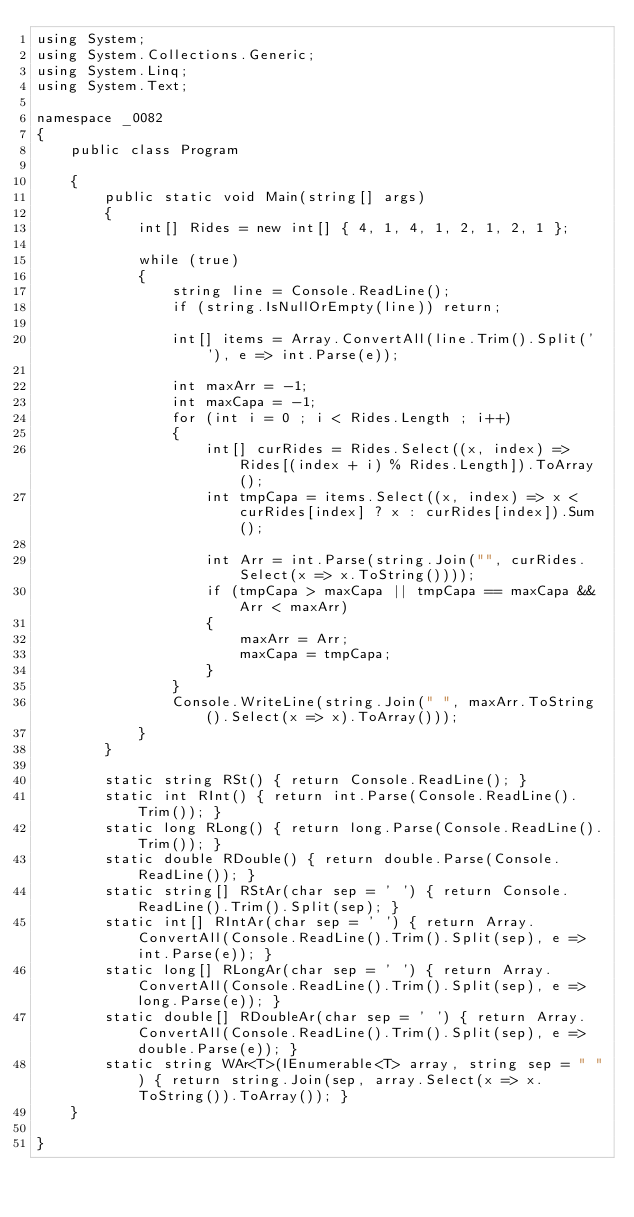<code> <loc_0><loc_0><loc_500><loc_500><_C#_>using System;
using System.Collections.Generic;
using System.Linq;
using System.Text;

namespace _0082
{
    public class Program

    {
        public static void Main(string[] args)
        {
            int[] Rides = new int[] { 4, 1, 4, 1, 2, 1, 2, 1 };

            while (true)
            {
                string line = Console.ReadLine();
                if (string.IsNullOrEmpty(line)) return;

                int[] items = Array.ConvertAll(line.Trim().Split(' '), e => int.Parse(e));

                int maxArr = -1;
                int maxCapa = -1;
                for (int i = 0 ; i < Rides.Length ; i++)
                {
                    int[] curRides = Rides.Select((x, index) => Rides[(index + i) % Rides.Length]).ToArray();
                    int tmpCapa = items.Select((x, index) => x < curRides[index] ? x : curRides[index]).Sum();

                    int Arr = int.Parse(string.Join("", curRides.Select(x => x.ToString())));
                    if (tmpCapa > maxCapa || tmpCapa == maxCapa && Arr < maxArr)
                    {
                        maxArr = Arr;
                        maxCapa = tmpCapa;
                    }
                }
                Console.WriteLine(string.Join(" ", maxArr.ToString().Select(x => x).ToArray()));
            }
        }

        static string RSt() { return Console.ReadLine(); }
        static int RInt() { return int.Parse(Console.ReadLine().Trim()); }
        static long RLong() { return long.Parse(Console.ReadLine().Trim()); }
        static double RDouble() { return double.Parse(Console.ReadLine()); }
        static string[] RStAr(char sep = ' ') { return Console.ReadLine().Trim().Split(sep); }
        static int[] RIntAr(char sep = ' ') { return Array.ConvertAll(Console.ReadLine().Trim().Split(sep), e => int.Parse(e)); }
        static long[] RLongAr(char sep = ' ') { return Array.ConvertAll(Console.ReadLine().Trim().Split(sep), e => long.Parse(e)); }
        static double[] RDoubleAr(char sep = ' ') { return Array.ConvertAll(Console.ReadLine().Trim().Split(sep), e => double.Parse(e)); }
        static string WAr<T>(IEnumerable<T> array, string sep = " ") { return string.Join(sep, array.Select(x => x.ToString()).ToArray()); }
    }

}

</code> 